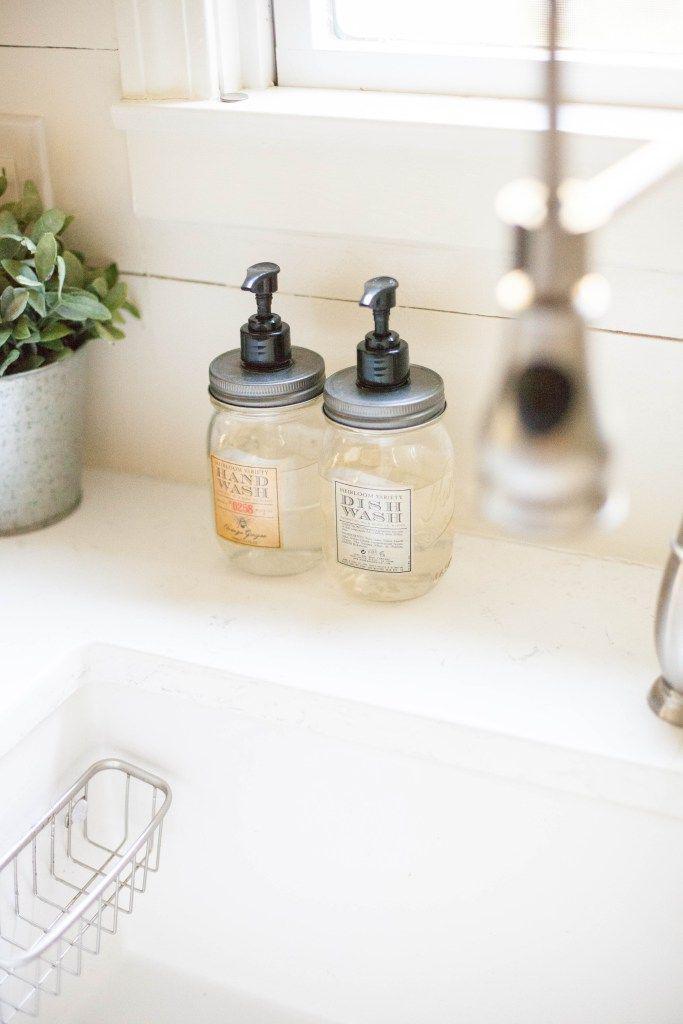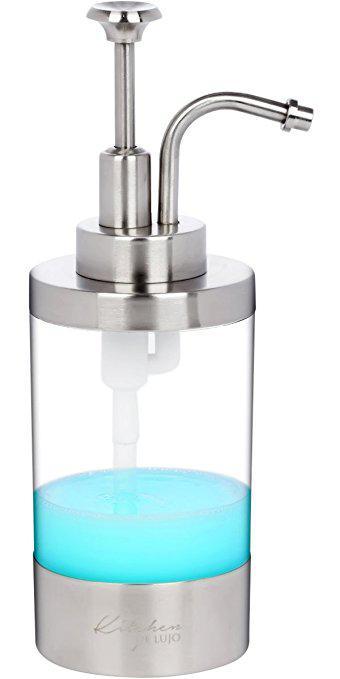The first image is the image on the left, the second image is the image on the right. For the images shown, is this caption "There is blue liquid visible inside a clear soap dispenser" true? Answer yes or no. Yes. The first image is the image on the left, the second image is the image on the right. Considering the images on both sides, is "An image shows a pump dispenser containing a blue liquid." valid? Answer yes or no. Yes. 